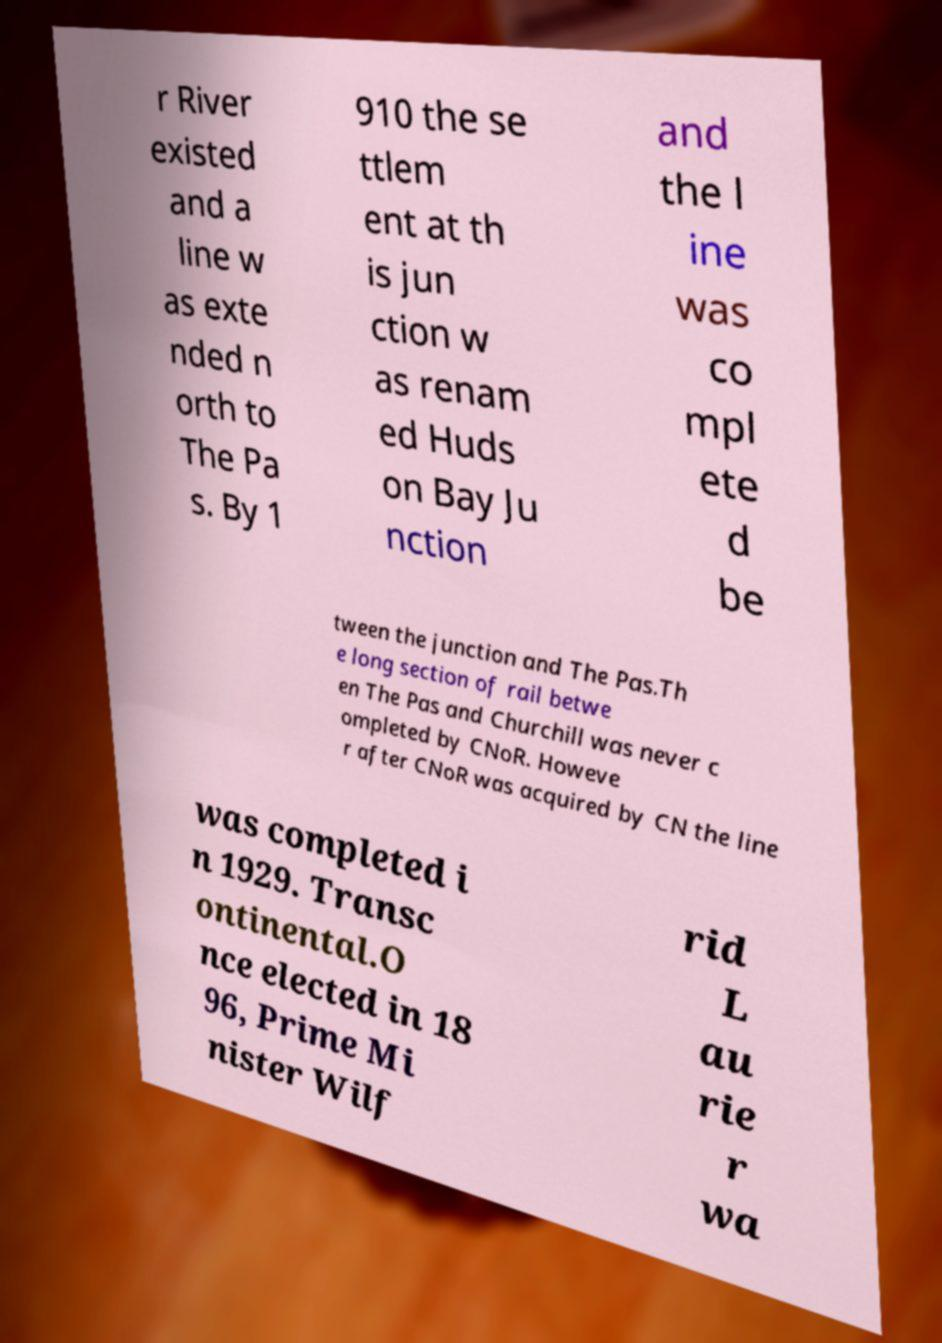Please read and relay the text visible in this image. What does it say? r River existed and a line w as exte nded n orth to The Pa s. By 1 910 the se ttlem ent at th is jun ction w as renam ed Huds on Bay Ju nction and the l ine was co mpl ete d be tween the junction and The Pas.Th e long section of rail betwe en The Pas and Churchill was never c ompleted by CNoR. Howeve r after CNoR was acquired by CN the line was completed i n 1929. Transc ontinental.O nce elected in 18 96, Prime Mi nister Wilf rid L au rie r wa 